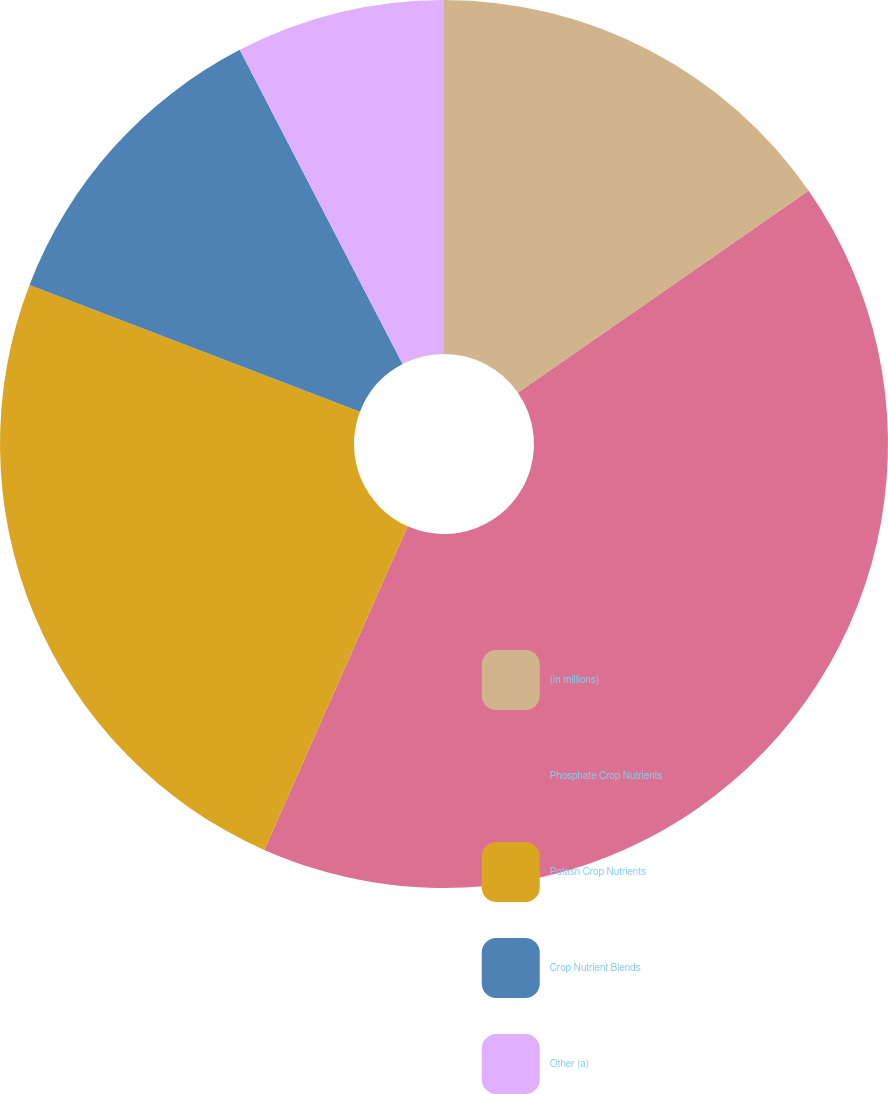Convert chart. <chart><loc_0><loc_0><loc_500><loc_500><pie_chart><fcel>(in millions)<fcel>Phosphate Crop Nutrients<fcel>Potash Crop Nutrients<fcel>Crop Nutrient Blends<fcel>Other (a)<nl><fcel>15.34%<fcel>41.3%<fcel>24.2%<fcel>11.56%<fcel>7.61%<nl></chart> 